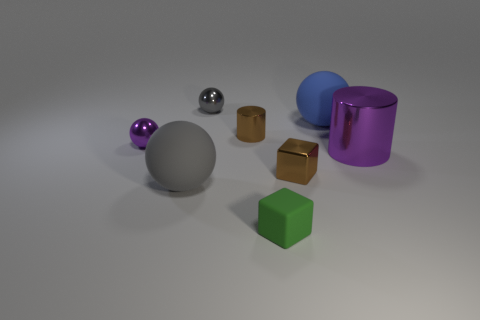How would you describe the lighting and shadows in the image? The lighting in the image is soft and diffused, casting gentle shadows that suggest an overhead light source. The shadows are relatively short, indicating the light source is not too far above the objects. Such lighting creates a calming atmosphere and subtly highlights the shapes of the objects.  What can you infer about the time of day or setting from the lighting? Given the controlled nature of both the shadows and the lighting, it suggests an indoor setting, possibly a studio environment where the lighting conditions are deliberately managed. It's difficult to infer the time of day due to the lack of any natural light indicators such as sunlight or shadows that change with the position of the sun. 